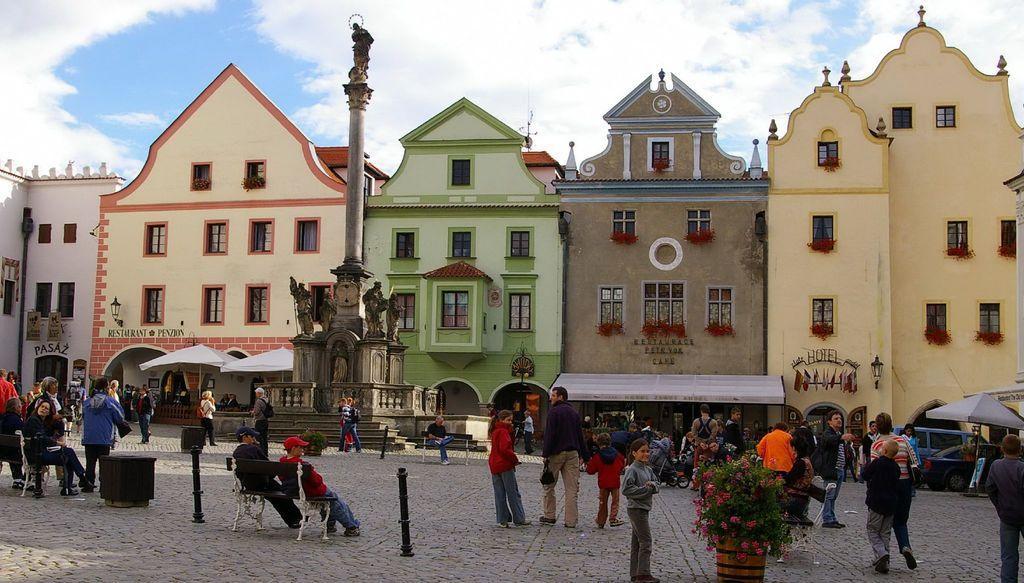Can you describe this image briefly? In this image, I can see few people standing and few people sitting. At the bottom of the image, I can see a flower pot with a plant. On the right side of the image, there are two cars on the road. There are buildings with windows, patio umbrellas and sculptures. In the background, there is the sky. 